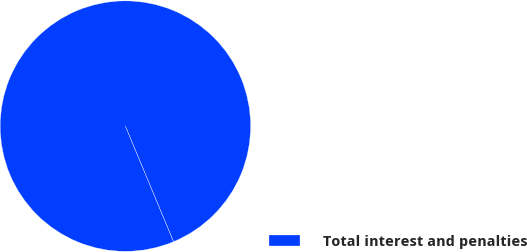<chart> <loc_0><loc_0><loc_500><loc_500><pie_chart><fcel>Total interest and penalties<nl><fcel>100.0%<nl></chart> 